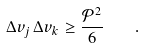Convert formula to latex. <formula><loc_0><loc_0><loc_500><loc_500>\Delta v _ { j } \, \Delta v _ { k } \geq \frac { \mathcal { P } ^ { 2 } } { 6 } \quad .</formula> 